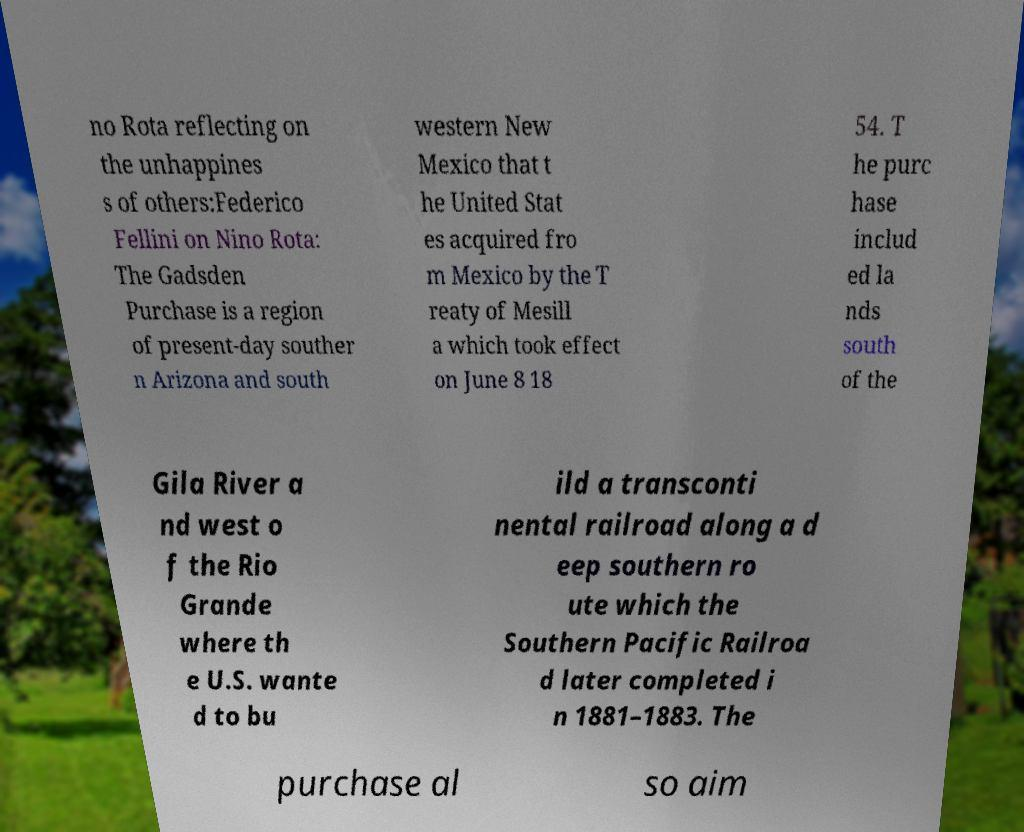Could you assist in decoding the text presented in this image and type it out clearly? no Rota reflecting on the unhappines s of others:Federico Fellini on Nino Rota: The Gadsden Purchase is a region of present-day souther n Arizona and south western New Mexico that t he United Stat es acquired fro m Mexico by the T reaty of Mesill a which took effect on June 8 18 54. T he purc hase includ ed la nds south of the Gila River a nd west o f the Rio Grande where th e U.S. wante d to bu ild a transconti nental railroad along a d eep southern ro ute which the Southern Pacific Railroa d later completed i n 1881–1883. The purchase al so aim 